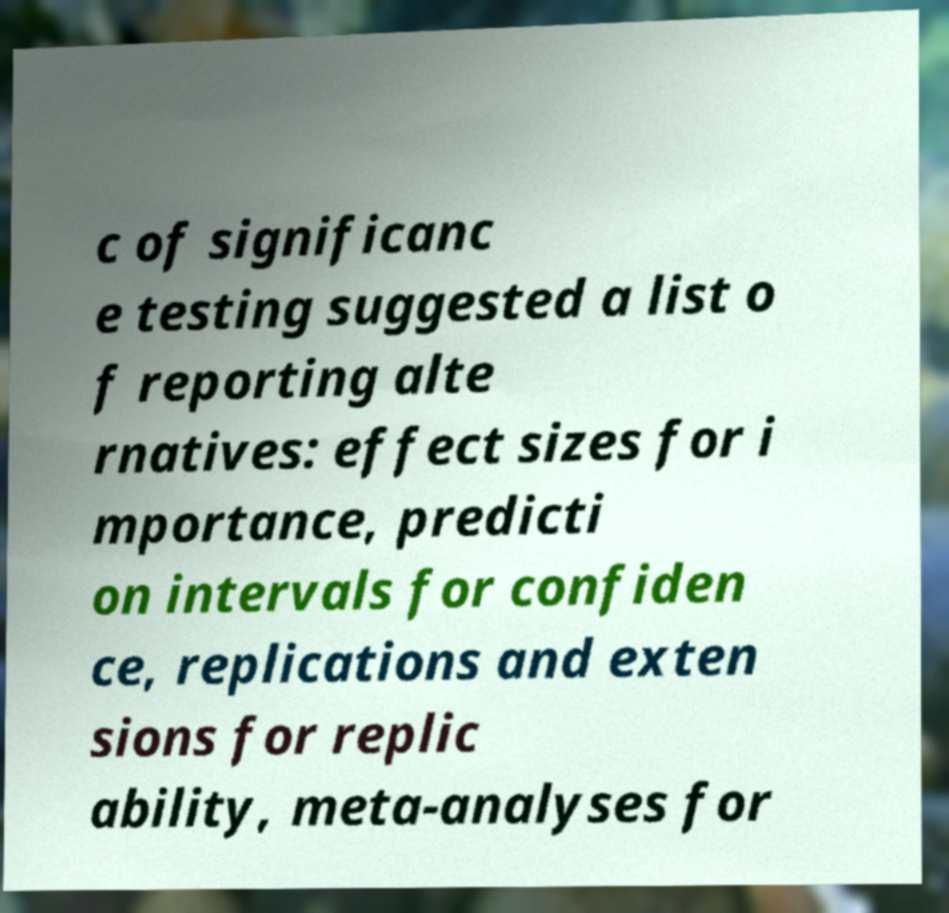Can you read and provide the text displayed in the image?This photo seems to have some interesting text. Can you extract and type it out for me? c of significanc e testing suggested a list o f reporting alte rnatives: effect sizes for i mportance, predicti on intervals for confiden ce, replications and exten sions for replic ability, meta-analyses for 